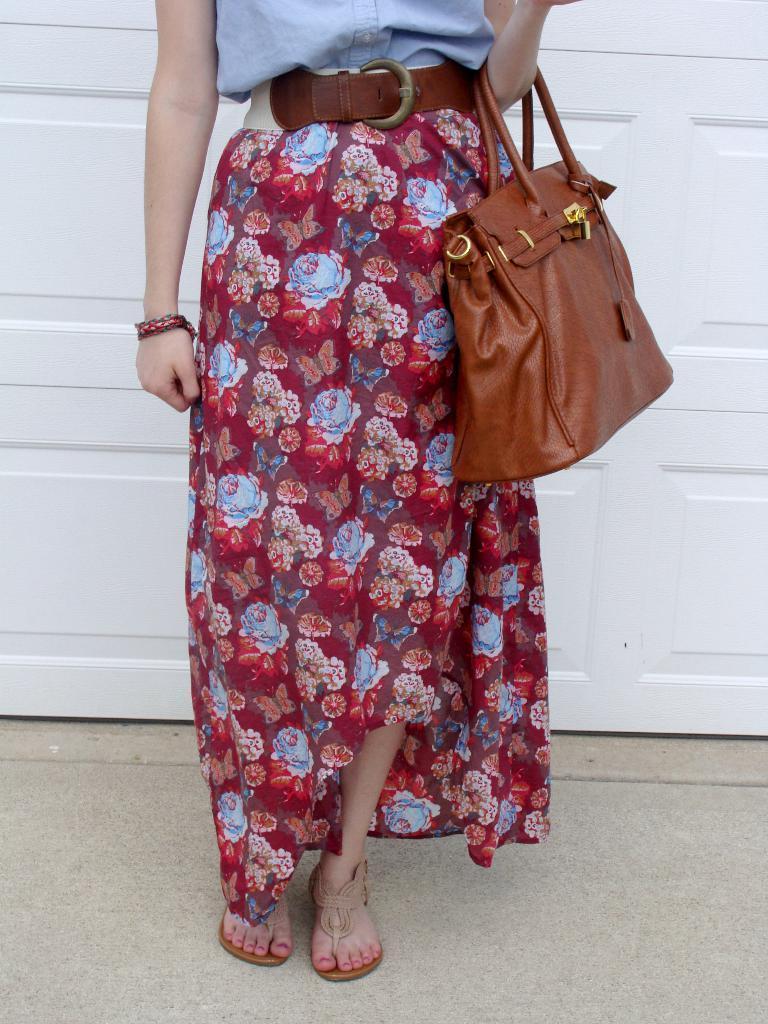Describe this image in one or two sentences. In this image we can see a person carrying a bag. Behind the person we can see a wooden object. 